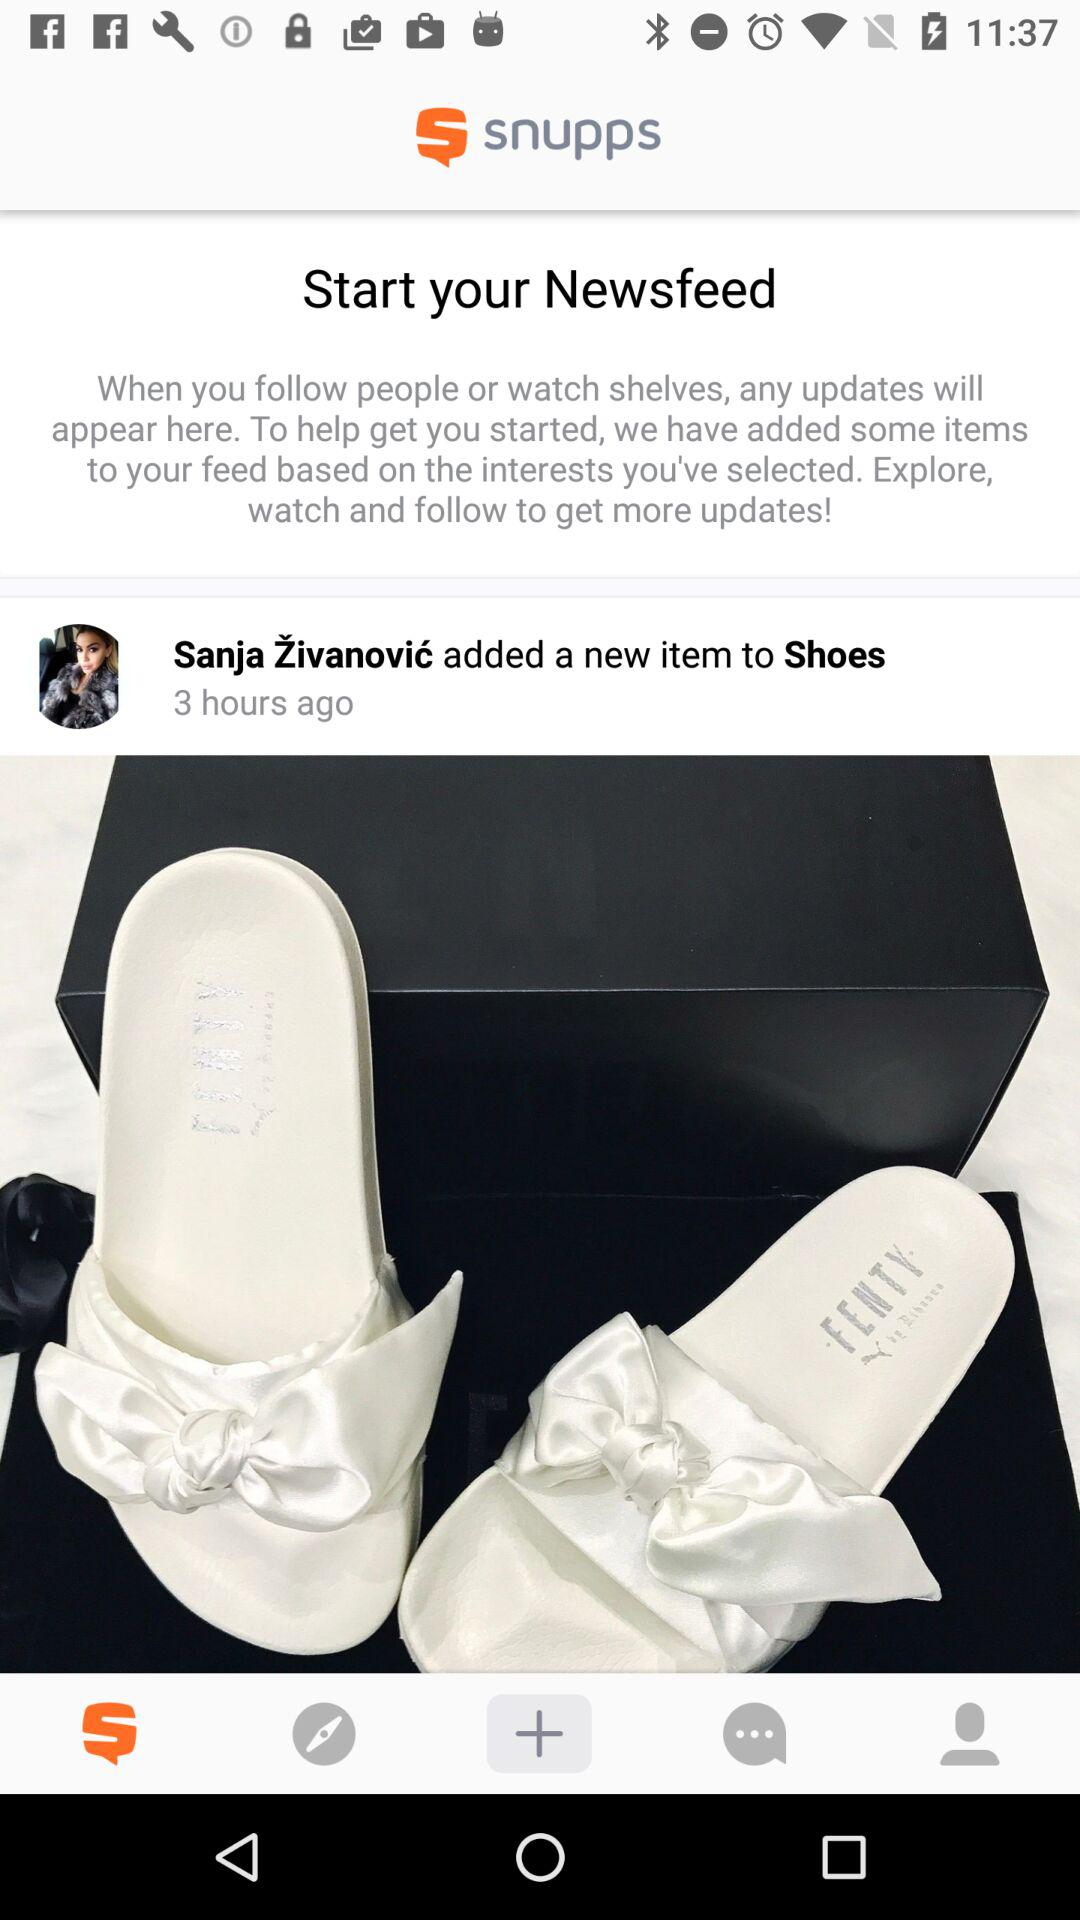When was the story published? The story published 3 hours ago. 